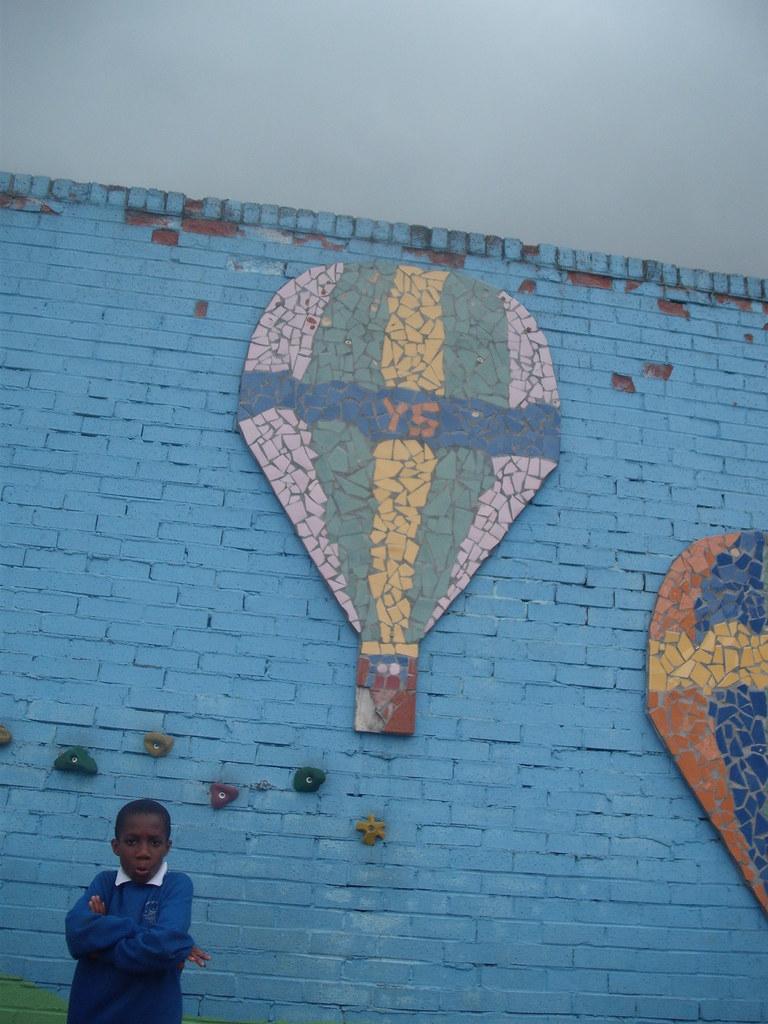In one or two sentences, can you explain what this image depicts? In this image I can see a person standing wearing blue color shirt, background the wall is in blue color and the sky is in white color. 